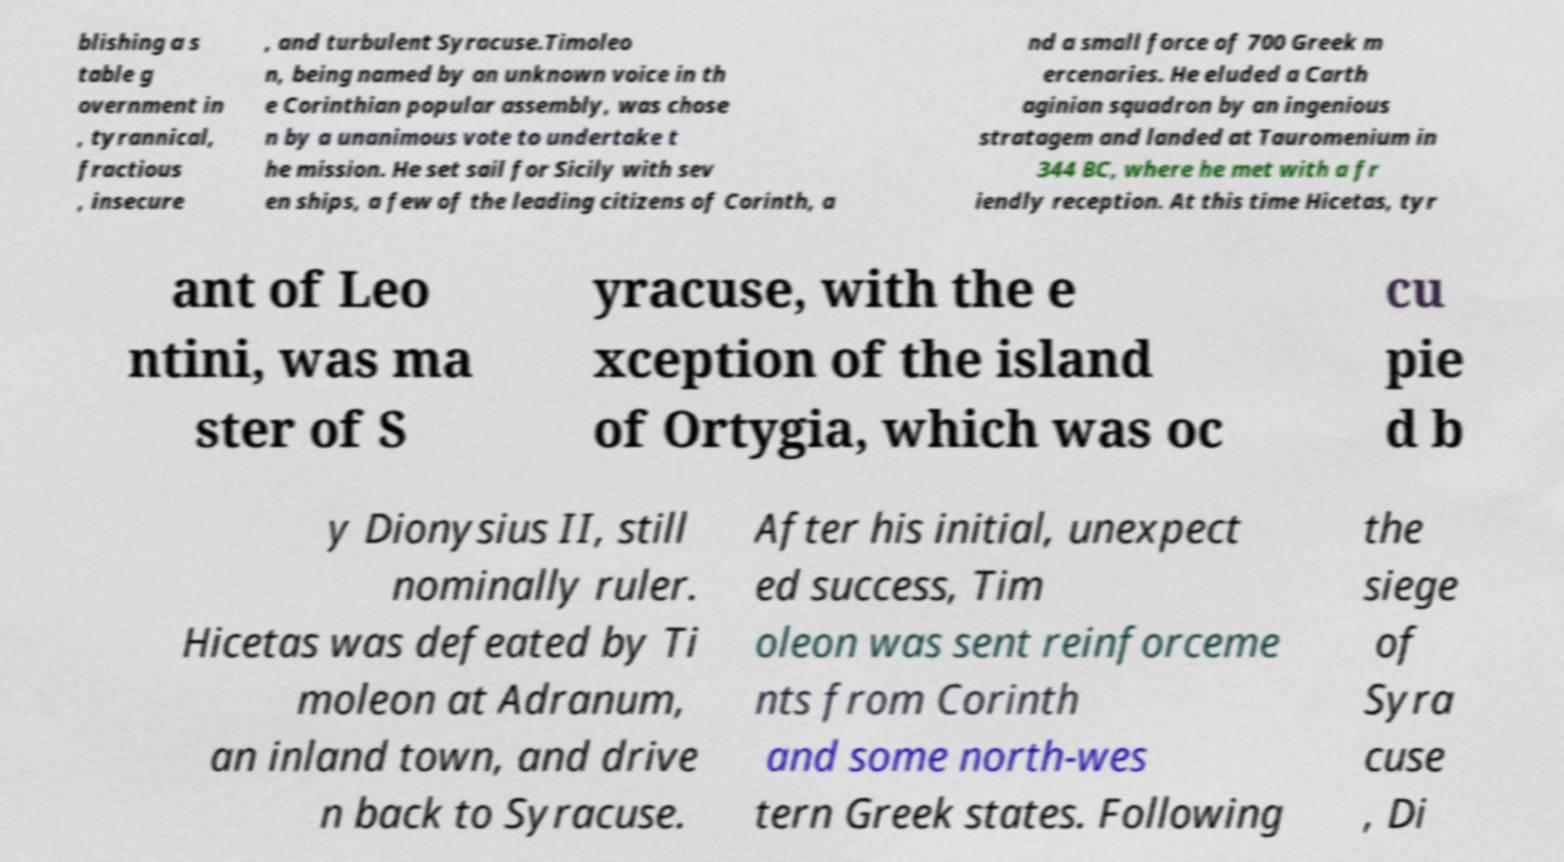I need the written content from this picture converted into text. Can you do that? blishing a s table g overnment in , tyrannical, fractious , insecure , and turbulent Syracuse.Timoleo n, being named by an unknown voice in th e Corinthian popular assembly, was chose n by a unanimous vote to undertake t he mission. He set sail for Sicily with sev en ships, a few of the leading citizens of Corinth, a nd a small force of 700 Greek m ercenaries. He eluded a Carth aginian squadron by an ingenious stratagem and landed at Tauromenium in 344 BC, where he met with a fr iendly reception. At this time Hicetas, tyr ant of Leo ntini, was ma ster of S yracuse, with the e xception of the island of Ortygia, which was oc cu pie d b y Dionysius II, still nominally ruler. Hicetas was defeated by Ti moleon at Adranum, an inland town, and drive n back to Syracuse. After his initial, unexpect ed success, Tim oleon was sent reinforceme nts from Corinth and some north-wes tern Greek states. Following the siege of Syra cuse , Di 